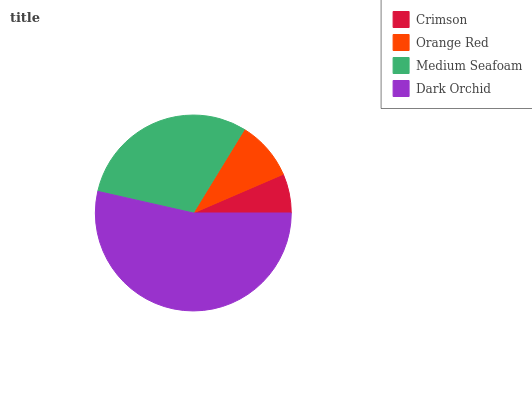Is Crimson the minimum?
Answer yes or no. Yes. Is Dark Orchid the maximum?
Answer yes or no. Yes. Is Orange Red the minimum?
Answer yes or no. No. Is Orange Red the maximum?
Answer yes or no. No. Is Orange Red greater than Crimson?
Answer yes or no. Yes. Is Crimson less than Orange Red?
Answer yes or no. Yes. Is Crimson greater than Orange Red?
Answer yes or no. No. Is Orange Red less than Crimson?
Answer yes or no. No. Is Medium Seafoam the high median?
Answer yes or no. Yes. Is Orange Red the low median?
Answer yes or no. Yes. Is Dark Orchid the high median?
Answer yes or no. No. Is Dark Orchid the low median?
Answer yes or no. No. 